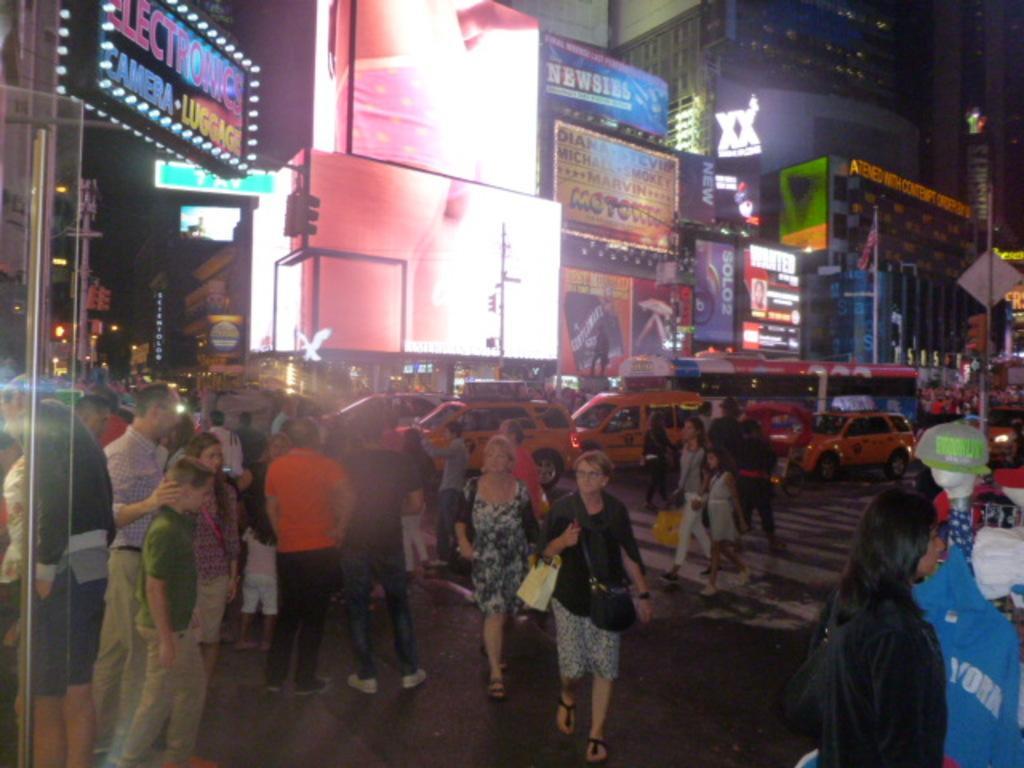Describe this image in one or two sentences. In this picture there are people and we can see mannequin with clothes,poles, traffic signals, board and flag. We can see vehicles on the road. In the background of the image we can see buildings, boards, hoardings, screens and lights. 